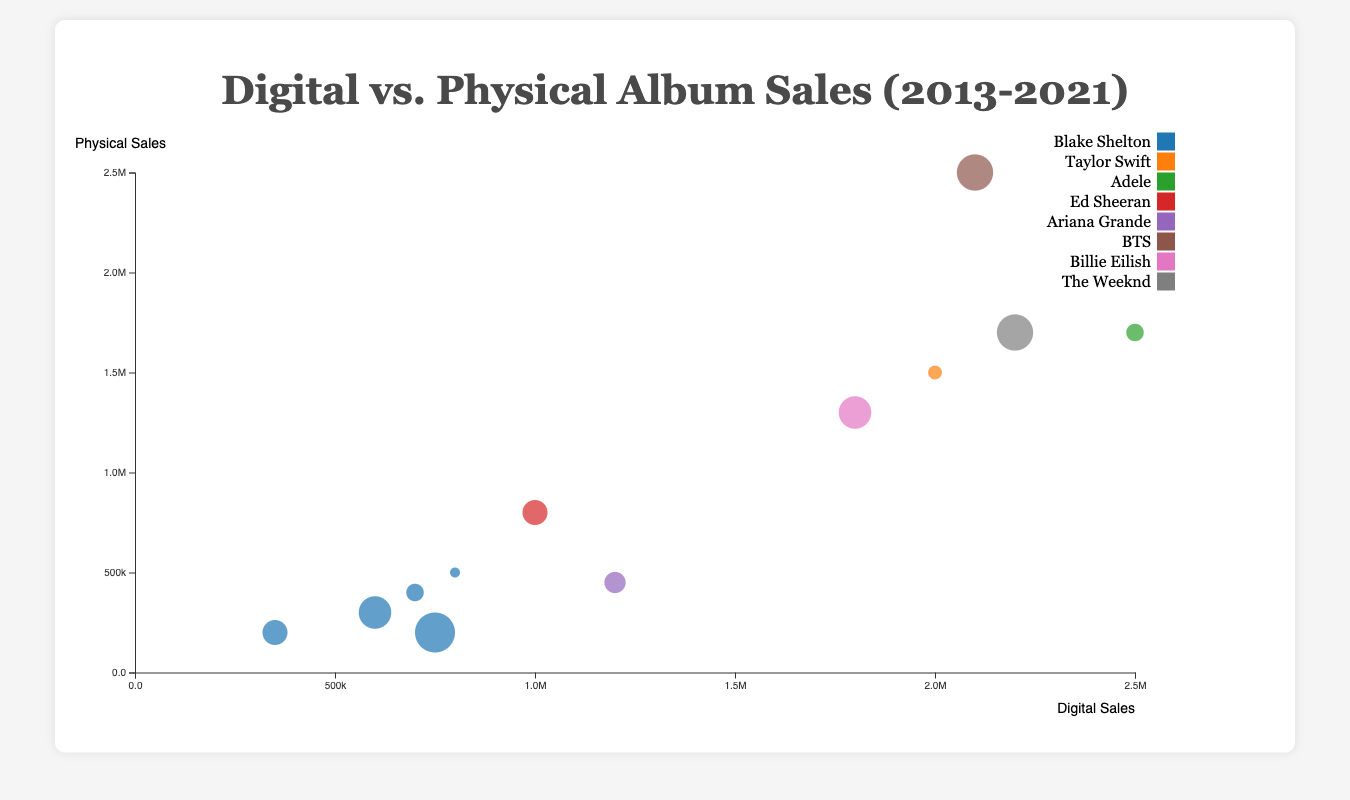What is the title of the chart? The title of the chart is displayed above the figure, it reads "Digital vs. Physical Album Sales (2013-2021)".
Answer: Digital vs. Physical Album Sales (2013-2021) Which artist has the highest digital sales in the year 2015? To find the artist with the highest digital sales in 2015, look at the bubbles for the year 2015 and compare their positions on the x-axis which represents digital sales. The highest digital sales in 2015 is by Adele.
Answer: Adele How do Blake Shelton's digital sales in 2013 compare to his digital sales in 2021? Find the bubbles for Blake Shelton in 2013 and 2021, note their positions on the x-axis. In 2013, his digital sales are 800,000 while in 2021, his digital sales are 750,000. Thus, his digital sales have slightly decreased.
Answer: Decreased Which country has the highest number of physical sales in 2017? Look at the bubbles corresponding to the year 2017 and note their y-axis positions, which represent physical sales. The highest physical sales in 2017 is by Ed Sheeran in Australia.
Answer: Australia How do the total digital sales by Blake Shelton in 2013, 2015, 2017, 2019, and 2021 compare to his total physical sales in the same years? Sum up Blake Shelton's digital sales for the years 2013 (800,000), 2015 (700,000), 2017 (350,000), 2019 (600,000), and 2021 (750,000). The total is 800,000 + 700,000 + 350,000 + 600,000 + 750,000 = 3,200,000. Then sum his physical sales for the same years: 500,000 + 400,000 + 200,000 + 300,000 + 200,000 = 1,600,000. Blake Shelton’s total digital sales are double his total physical sales over these years.
Answer: 3,200,000 vs 1,600,000 Which artist has the largest bubble size and what does it represent? The largest bubble size represents the most recent year, used in this chart to represent the year 2020. The artist with the largest bubble corresponds to BTS.
Answer: BTS What are the total digital sales of all artists in the year 2020? Identify the bubbles for the year 2020 and sum their digital sales. BTS (2,100,000) and The Weeknd (2,200,000). The total digital sales for the year 2020 are 2,100,000 + 2,200,000 = 4,300,000.
Answer: 4,300,000 Which artist has the highest combined digital and physical sales in a single year? Find the artist with the highest combination of digital and physical sales by adding both values for each bubble. The highest combined sales are for Adele in 2015 with 2,500,000 digital and 1,700,000 physical sales, totaling 4,200,000.
Answer: Adele 